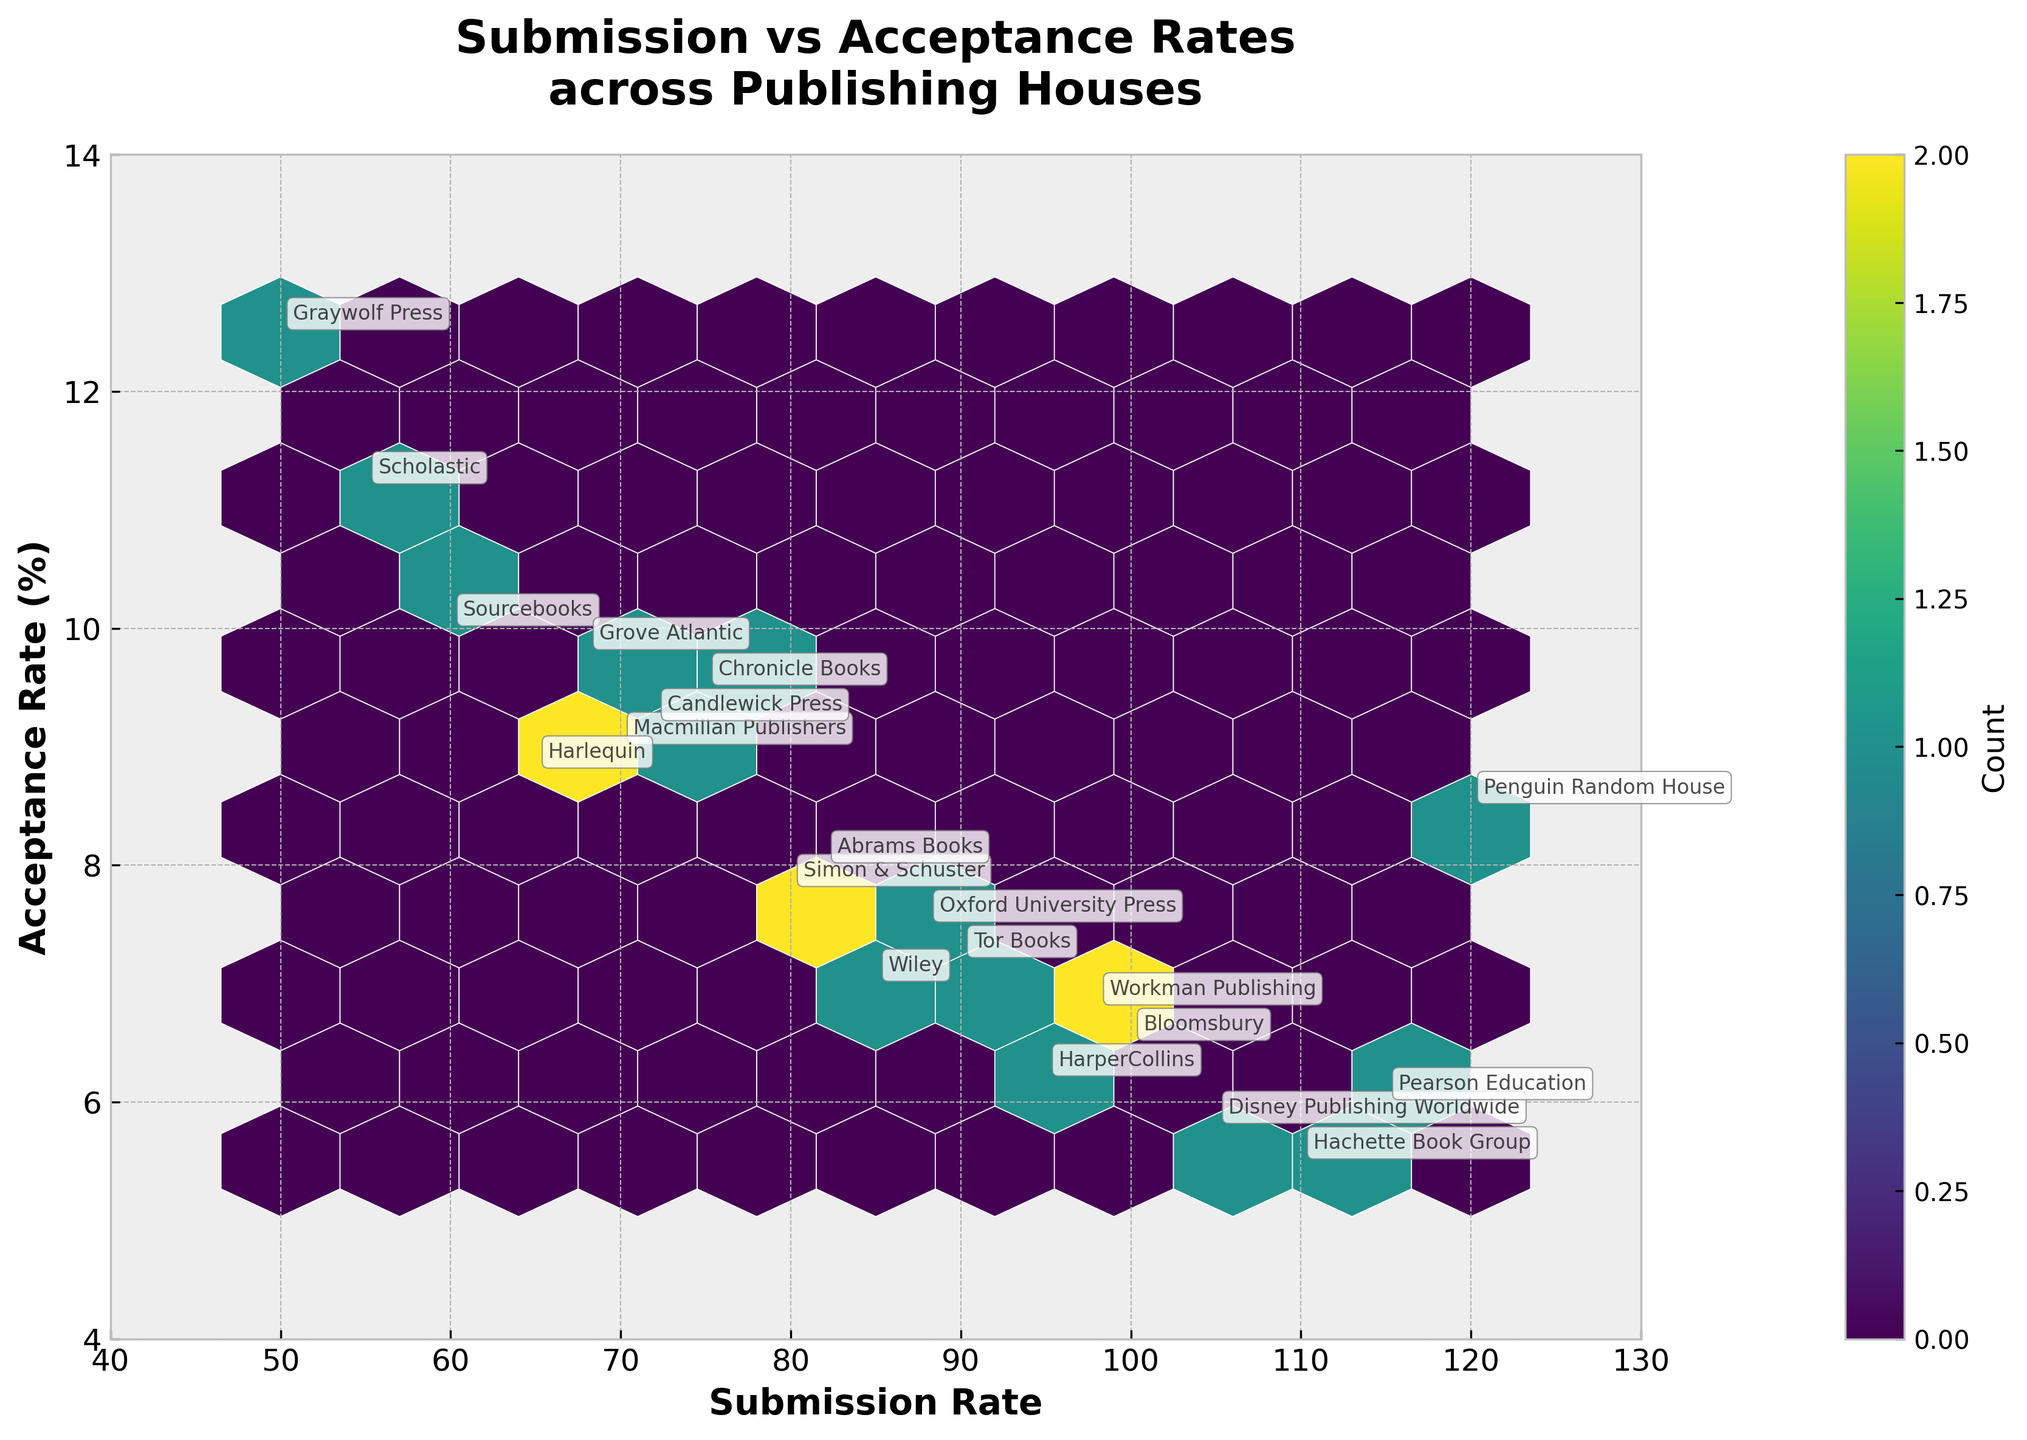what is the title of the figure? The Title can be seen at the top of the figure. It states "Submission vs Acceptance Rates across Publishing Houses" which provides an overview of the content and context of the plot.
Answer: Submission vs Acceptance Rates across Publishing Houses what are the labels for the X and Y axes? The labels for the axes are provided near the ticks along the X and Y axes. The X-axis is labeled "Submission Rate," and the Y-axis is labeled "Acceptance Rate (%)".
Answer: Submission Rate, Acceptance Rate (%) what is the range of the submission rate on the X-axis? The X-axis range is shown along the bottom of the figure. It begins at 40 and ends at 130. This range encompasses all the submission rate values presented.
Answer: 40 to 130 how many hexagons are present in the hexbin plot? By careful observation, one can count the hexagons presented in the plot. Each hexagon corresponds to a bin generated by the hexbin function. This is a bit tricky as overlapping and edge hexagons may need careful counting. Approximately, there are 20 hexagons.
Answer: Approximately 20 which publishing house has the highest acceptance rate? From the annotations on the plot, find the point with the highest Y-axis value. Graywolf Press has the highest acceptance rate at 12.5%.
Answer: Graywolf Press which publishing house has the lowest acceptance rate and what is it? Examine the data points displayed on the plot, find the lowest Y-axis value. Hachette Book Group has the lowest acceptance rate at 5.5%.
Answer: Hachette Book Group, 5.5% how many publishing houses have a submission rate between 70 and 90? By looking at the X-axis, identify data points within the 70 to 90 range. The publishing houses falling in this interval are Macmillan Publishers, Harlequin, Chronicle Books, and Sourcebooks, so there are four publishing houses.
Answer: 4 what is the count of data points associated with the densest hexagon? Hexagons with more data points are colored differently. The color bar helps in identifying the count. The densest hexagon, as indicated by the color bar, contains approximately 2 data points.
Answer: About 2 which publishing house is an outlier in terms of having a high acceptance rate but low submission rate? Look for points that are isolated from the majority. Graywolf Press is an outlier with a high acceptance rate of 12.5% and a relatively low submission rate of 50.
Answer: Graywolf Press 